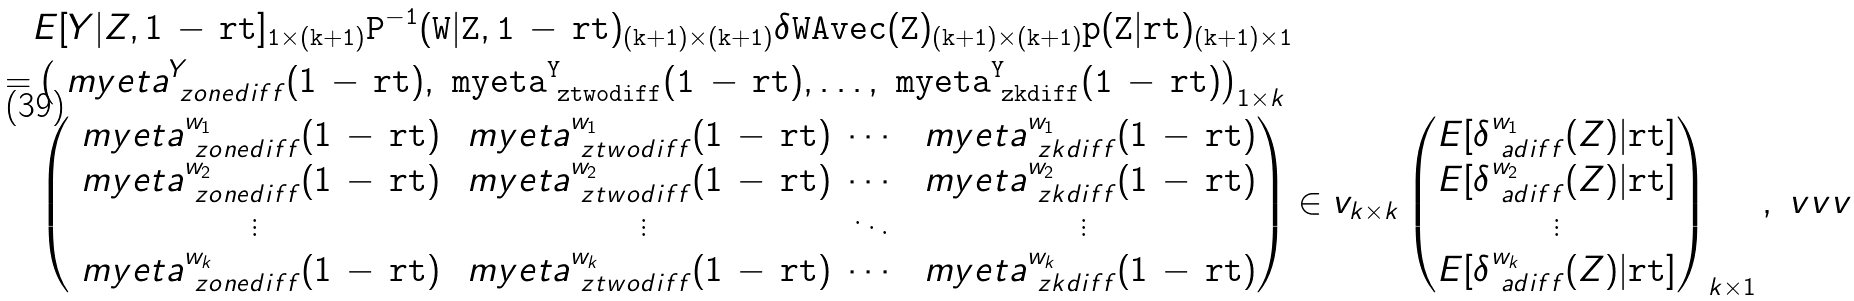Convert formula to latex. <formula><loc_0><loc_0><loc_500><loc_500>& E [ Y | Z , 1 \, - \, \tt r t ] _ { 1 \times ( k + 1 ) } P ^ { - 1 } ( W | Z , 1 \, - \, \tt r t ) _ { ( k + 1 ) \times ( k + 1 ) } \delta W A v e c ( Z ) _ { ( k + 1 ) \times ( k + 1 ) } p ( Z | \tt r t ) _ { ( k + 1 ) \times 1 } \\ = & \left ( \ m y e t a ^ { Y } _ { \ z o n e d i f f } ( 1 \, - \, \tt r t ) , \ m y e t a ^ { Y } _ { \ z t w o d i f f } ( 1 \, - \, \tt r t ) , \dots , \ m y e t a ^ { Y } _ { \ z k d i f f } ( 1 \, - \, \tt r t ) \right ) _ { 1 \times k } \\ & \begin{pmatrix} \ m y e t a ^ { w _ { 1 } } _ { \ z o n e d i f f } ( 1 \, - \, \tt r t ) & \ m y e t a ^ { w _ { 1 } } _ { \ z t w o d i f f } ( 1 \, - \, \tt r t ) & \cdots & \ m y e t a ^ { w _ { 1 } } _ { \ z k d i f f } ( 1 \, - \, \tt r t ) \\ \ m y e t a ^ { w _ { 2 } } _ { \ z o n e d i f f } ( 1 \, - \, \tt r t ) & \ m y e t a ^ { w _ { 2 } } _ { \ z t w o d i f f } ( 1 \, - \, \tt r t ) & \cdots & \ m y e t a ^ { w _ { 2 } } _ { \ z k d i f f } ( 1 \, - \, \tt r t ) \\ \vdots & \vdots & \ddots & \vdots \\ \ m y e t a ^ { w _ { k } } _ { \ z o n e d i f f } ( 1 \, - \, \tt r t ) & \ m y e t a ^ { w _ { k } } _ { \ z t w o d i f f } ( 1 \, - \, \tt r t ) & \cdots & \ m y e t a ^ { w _ { k } } _ { \ z k d i f f } ( 1 \, - \, \tt r t ) \end{pmatrix} \in v _ { k \times k } \begin{pmatrix} E [ \delta ^ { w _ { 1 } } _ { \ a d i f f } ( Z ) | \tt r t ] \\ E [ \delta ^ { w _ { 2 } } _ { \ a d i f f } ( Z ) | \tt r t ] \\ \vdots \\ E [ \delta ^ { w _ { k } } _ { \ a d i f f } ( Z ) | \tt r t ] \end{pmatrix} _ { k \times 1 } , \ v v v</formula> 